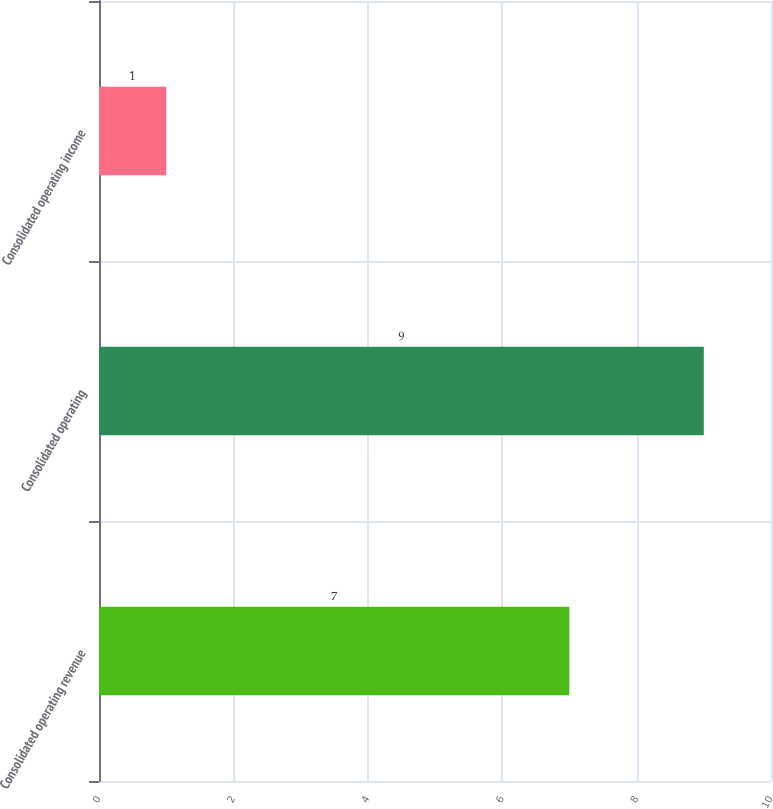Convert chart to OTSL. <chart><loc_0><loc_0><loc_500><loc_500><bar_chart><fcel>Consolidated operating revenue<fcel>Consolidated operating<fcel>Consolidated operating income<nl><fcel>7<fcel>9<fcel>1<nl></chart> 